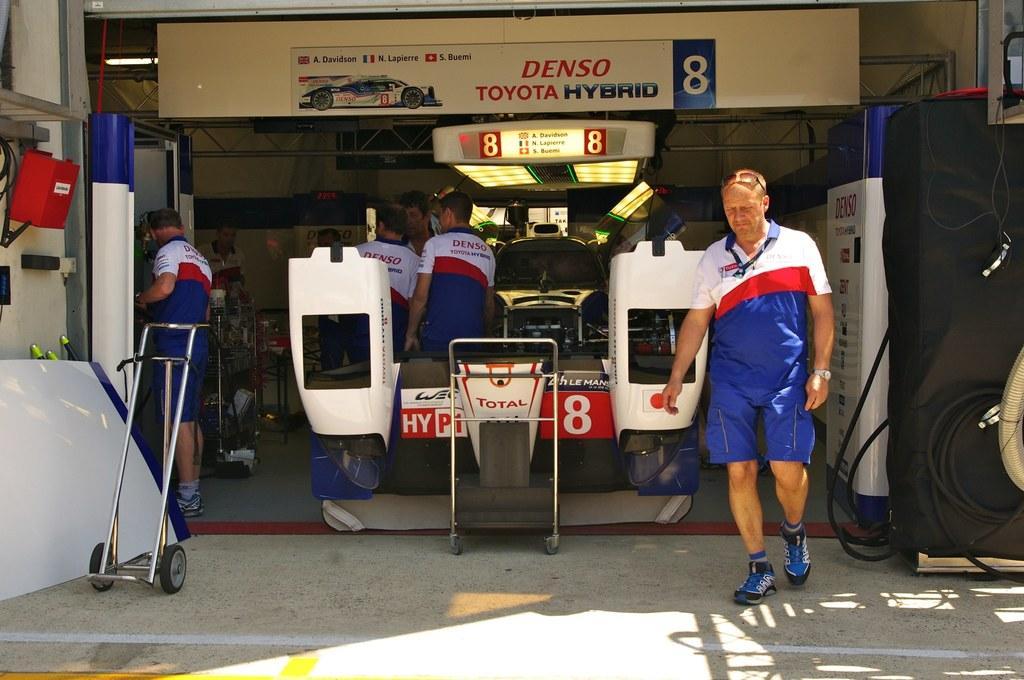In one or two sentences, can you explain what this image depicts? In this image I can see the group of people with blue, red and white color dresses. These people are under the tent. I can see some machines in-front of these people. To the left I can see the trolley. In the background I can see the boards and lights. 